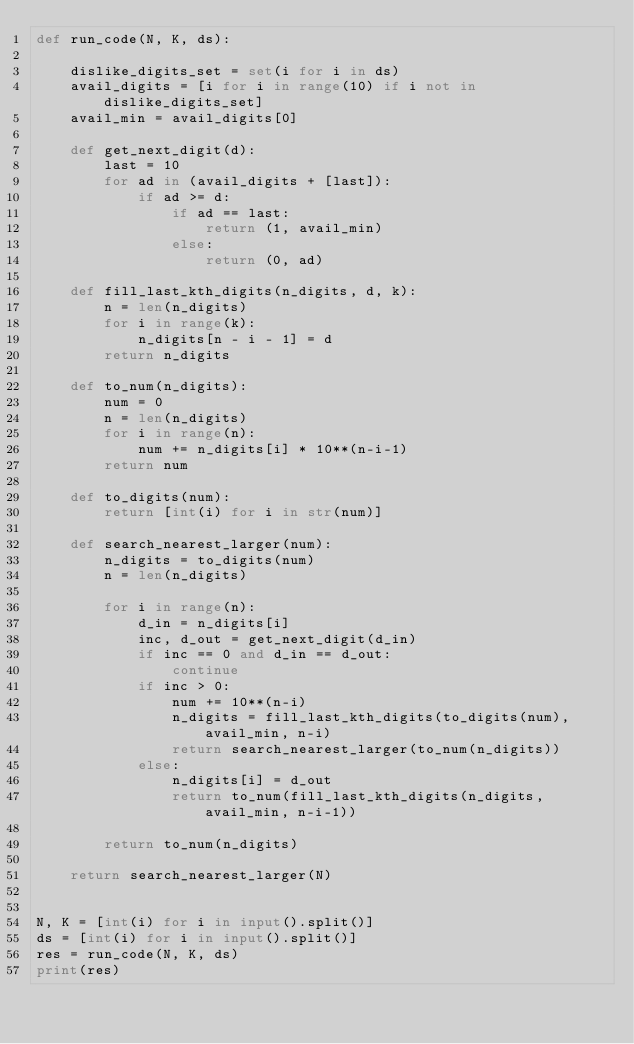Convert code to text. <code><loc_0><loc_0><loc_500><loc_500><_Python_>def run_code(N, K, ds):

    dislike_digits_set = set(i for i in ds)
    avail_digits = [i for i in range(10) if i not in dislike_digits_set]
    avail_min = avail_digits[0]

    def get_next_digit(d):
        last = 10
        for ad in (avail_digits + [last]):
            if ad >= d:
                if ad == last:
                    return (1, avail_min)
                else:
                    return (0, ad)

    def fill_last_kth_digits(n_digits, d, k):
        n = len(n_digits)
        for i in range(k):
            n_digits[n - i - 1] = d
        return n_digits

    def to_num(n_digits):
        num = 0
        n = len(n_digits)
        for i in range(n):
            num += n_digits[i] * 10**(n-i-1)
        return num

    def to_digits(num):
        return [int(i) for i in str(num)]

    def search_nearest_larger(num):
        n_digits = to_digits(num)
        n = len(n_digits)

        for i in range(n):
            d_in = n_digits[i]
            inc, d_out = get_next_digit(d_in)
            if inc == 0 and d_in == d_out:
                continue
            if inc > 0:
                num += 10**(n-i)
                n_digits = fill_last_kth_digits(to_digits(num), avail_min, n-i)
                return search_nearest_larger(to_num(n_digits))
            else:
                n_digits[i] = d_out
                return to_num(fill_last_kth_digits(n_digits, avail_min, n-i-1))

        return to_num(n_digits)

    return search_nearest_larger(N)


N, K = [int(i) for i in input().split()]
ds = [int(i) for i in input().split()]
res = run_code(N, K, ds)
print(res)
</code> 